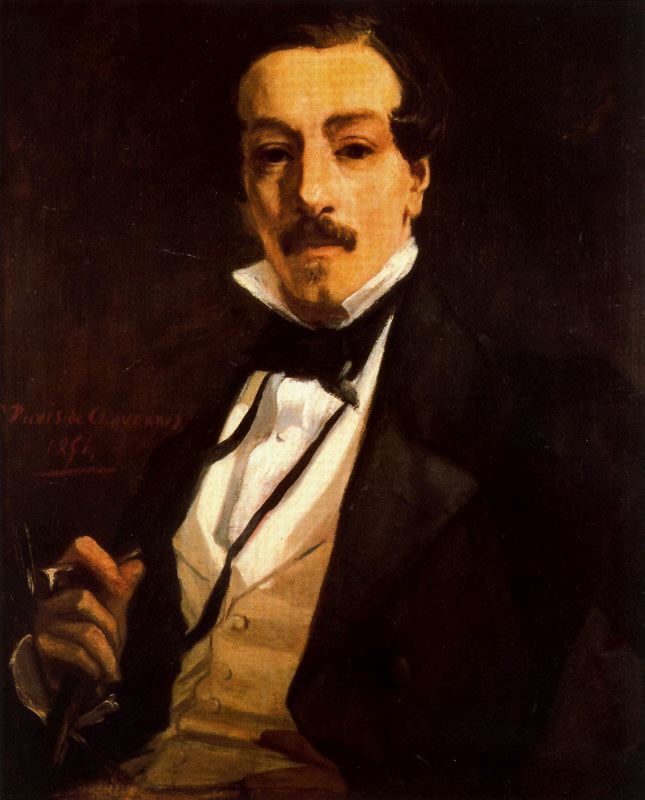If this portrait was a part of a larger narrative in a novel, what role might the subject play? In a novel, the subject of this portrait could play the role of a brilliant yet enigmatic protagonist. Perhaps he is a renowned author or a scholar with a mysterious past, whose writings have influenced many but who remains a reclusive figure. The pen in his hand might serve as a metaphor for his control over the narrative, wielding the power to influence through his words. His formal attire suggests he is someone of great respect and reputation, and the dark background hints at a hidden depth to his character or past—unexplored areas of his life that add a layer of intrigue. He could be a character whose thoughts and writings drive the plot, uncovering secrets and providing wisdom, with the portrait serving as the introduction to his complex personality. What might a brief interaction between this character and another character in the novel look like? In a dimly lit study, the reclusive scholar sat behind a mahogany desk, his fingers lightly tapping the pen against the wooden surface. A knock echoed through the room. Reluctantly, he looked up, eyes filled with curiosity and caution.
'Enter,' he said softly. The door creaked open, revealing a young woman, her expression a mix of apprehension and determination.
'The article you wrote,' she began, her voice trembling slightly, 'it spoke of a hidden truth, one that… that my father knew.'
He raised an eyebrow, twisting the pen thoughtfully. 'And your father is?' he inquired, his voice calm yet probing.
'Dr. Malcolm Foster,' she replied, stepping further into the room. He leaned back, the recognition evident in his eyes.
'Interesting,' he murmured, 'very interesting indeed.' 